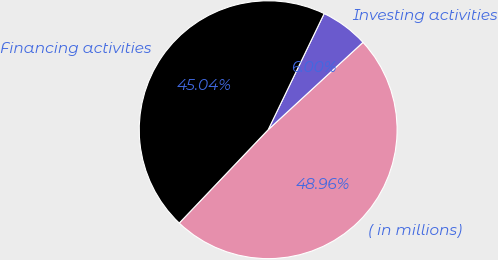Convert chart to OTSL. <chart><loc_0><loc_0><loc_500><loc_500><pie_chart><fcel>( in millions)<fcel>Investing activities<fcel>Financing activities<nl><fcel>48.96%<fcel>6.0%<fcel>45.04%<nl></chart> 